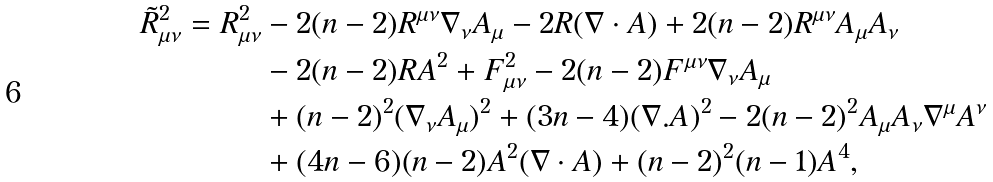<formula> <loc_0><loc_0><loc_500><loc_500>\tilde { R } ^ { 2 } _ { \mu \nu } = R ^ { 2 } _ { \mu \nu } & - 2 ( n - 2 ) R ^ { \mu \nu } \nabla _ { \nu } A _ { \mu } - 2 R ( \nabla \cdot A ) + 2 ( n - 2 ) R ^ { \mu \nu } A _ { \mu } A _ { \nu } \\ & - 2 ( n - 2 ) R A ^ { 2 } + F _ { \mu \nu } ^ { 2 } - 2 ( n - 2 ) F ^ { \mu \nu } \nabla _ { \nu } A _ { \mu } \\ & + ( n - 2 ) ^ { 2 } ( \nabla _ { \nu } A _ { \mu } ) ^ { 2 } + ( 3 n - 4 ) ( \nabla . A ) ^ { 2 } - 2 ( n - 2 ) ^ { 2 } A _ { \mu } A _ { \nu } \nabla ^ { \mu } A ^ { \nu } \\ & + ( 4 n - 6 ) ( n - 2 ) A ^ { 2 } ( \nabla \cdot A ) + ( n - 2 ) ^ { 2 } ( n - 1 ) A ^ { 4 } ,</formula> 